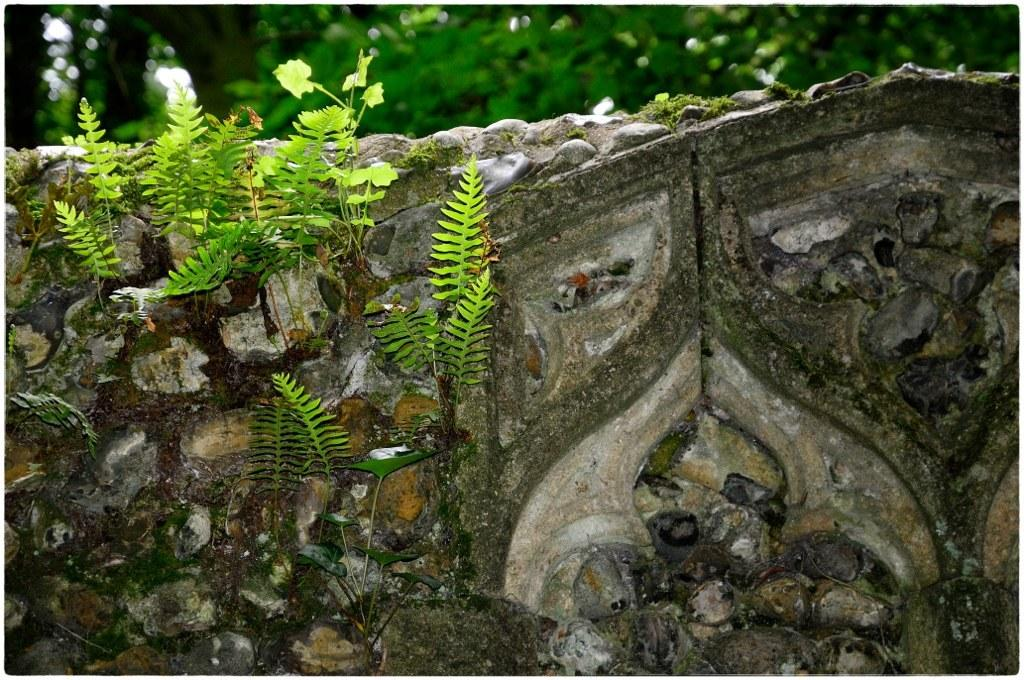What is present on the wall in the image? There are plants on the wall in the image. What can be said about the color of the plants? The plants are green in color. What is visible in the background of the image? There are trees visible in the background of the image. What type of development is taking place in the image? There is no development project or construction visible in the image; it primarily features plants on a wall and trees in the background. What songs can be heard playing in the background of the image? There is no audio or music present in the image; it is a still photograph. 